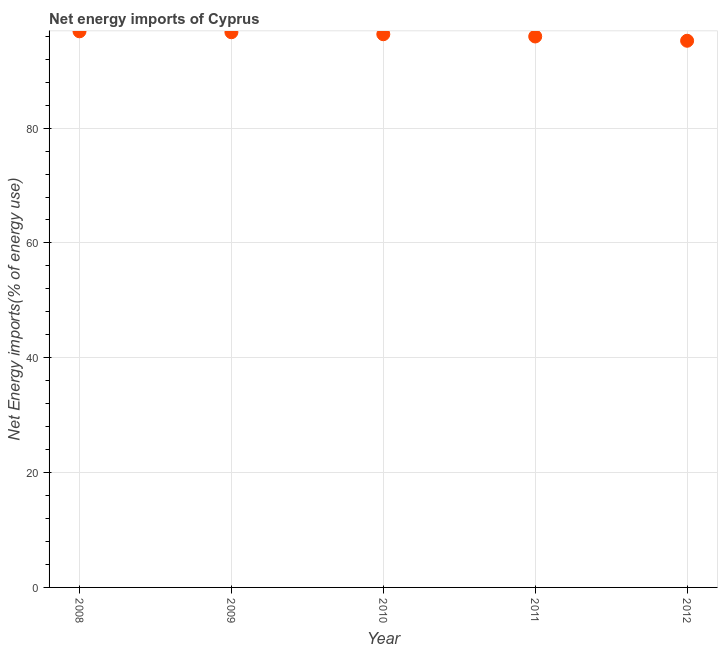What is the energy imports in 2010?
Keep it short and to the point. 96.35. Across all years, what is the maximum energy imports?
Offer a very short reply. 96.86. Across all years, what is the minimum energy imports?
Offer a very short reply. 95.21. In which year was the energy imports maximum?
Ensure brevity in your answer.  2008. In which year was the energy imports minimum?
Make the answer very short. 2012. What is the sum of the energy imports?
Your answer should be compact. 481.08. What is the difference between the energy imports in 2008 and 2009?
Offer a very short reply. 0.16. What is the average energy imports per year?
Offer a terse response. 96.22. What is the median energy imports?
Provide a succinct answer. 96.35. In how many years, is the energy imports greater than 24 %?
Make the answer very short. 5. Do a majority of the years between 2010 and 2008 (inclusive) have energy imports greater than 36 %?
Your response must be concise. No. What is the ratio of the energy imports in 2011 to that in 2012?
Keep it short and to the point. 1.01. Is the difference between the energy imports in 2008 and 2009 greater than the difference between any two years?
Offer a very short reply. No. What is the difference between the highest and the second highest energy imports?
Your response must be concise. 0.16. What is the difference between the highest and the lowest energy imports?
Provide a short and direct response. 1.65. In how many years, is the energy imports greater than the average energy imports taken over all years?
Offer a terse response. 3. How many years are there in the graph?
Keep it short and to the point. 5. What is the difference between two consecutive major ticks on the Y-axis?
Provide a succinct answer. 20. Does the graph contain any zero values?
Give a very brief answer. No. What is the title of the graph?
Ensure brevity in your answer.  Net energy imports of Cyprus. What is the label or title of the Y-axis?
Ensure brevity in your answer.  Net Energy imports(% of energy use). What is the Net Energy imports(% of energy use) in 2008?
Provide a succinct answer. 96.86. What is the Net Energy imports(% of energy use) in 2009?
Your response must be concise. 96.7. What is the Net Energy imports(% of energy use) in 2010?
Provide a succinct answer. 96.35. What is the Net Energy imports(% of energy use) in 2011?
Offer a very short reply. 95.96. What is the Net Energy imports(% of energy use) in 2012?
Offer a very short reply. 95.21. What is the difference between the Net Energy imports(% of energy use) in 2008 and 2009?
Offer a very short reply. 0.16. What is the difference between the Net Energy imports(% of energy use) in 2008 and 2010?
Your answer should be very brief. 0.51. What is the difference between the Net Energy imports(% of energy use) in 2008 and 2011?
Your answer should be compact. 0.9. What is the difference between the Net Energy imports(% of energy use) in 2008 and 2012?
Offer a terse response. 1.65. What is the difference between the Net Energy imports(% of energy use) in 2009 and 2010?
Your answer should be compact. 0.35. What is the difference between the Net Energy imports(% of energy use) in 2009 and 2011?
Give a very brief answer. 0.74. What is the difference between the Net Energy imports(% of energy use) in 2009 and 2012?
Keep it short and to the point. 1.48. What is the difference between the Net Energy imports(% of energy use) in 2010 and 2011?
Your answer should be very brief. 0.39. What is the difference between the Net Energy imports(% of energy use) in 2010 and 2012?
Your response must be concise. 1.14. What is the difference between the Net Energy imports(% of energy use) in 2011 and 2012?
Provide a short and direct response. 0.75. What is the ratio of the Net Energy imports(% of energy use) in 2009 to that in 2010?
Provide a succinct answer. 1. What is the ratio of the Net Energy imports(% of energy use) in 2009 to that in 2011?
Keep it short and to the point. 1.01. What is the ratio of the Net Energy imports(% of energy use) in 2010 to that in 2011?
Ensure brevity in your answer.  1. What is the ratio of the Net Energy imports(% of energy use) in 2010 to that in 2012?
Your answer should be very brief. 1.01. 